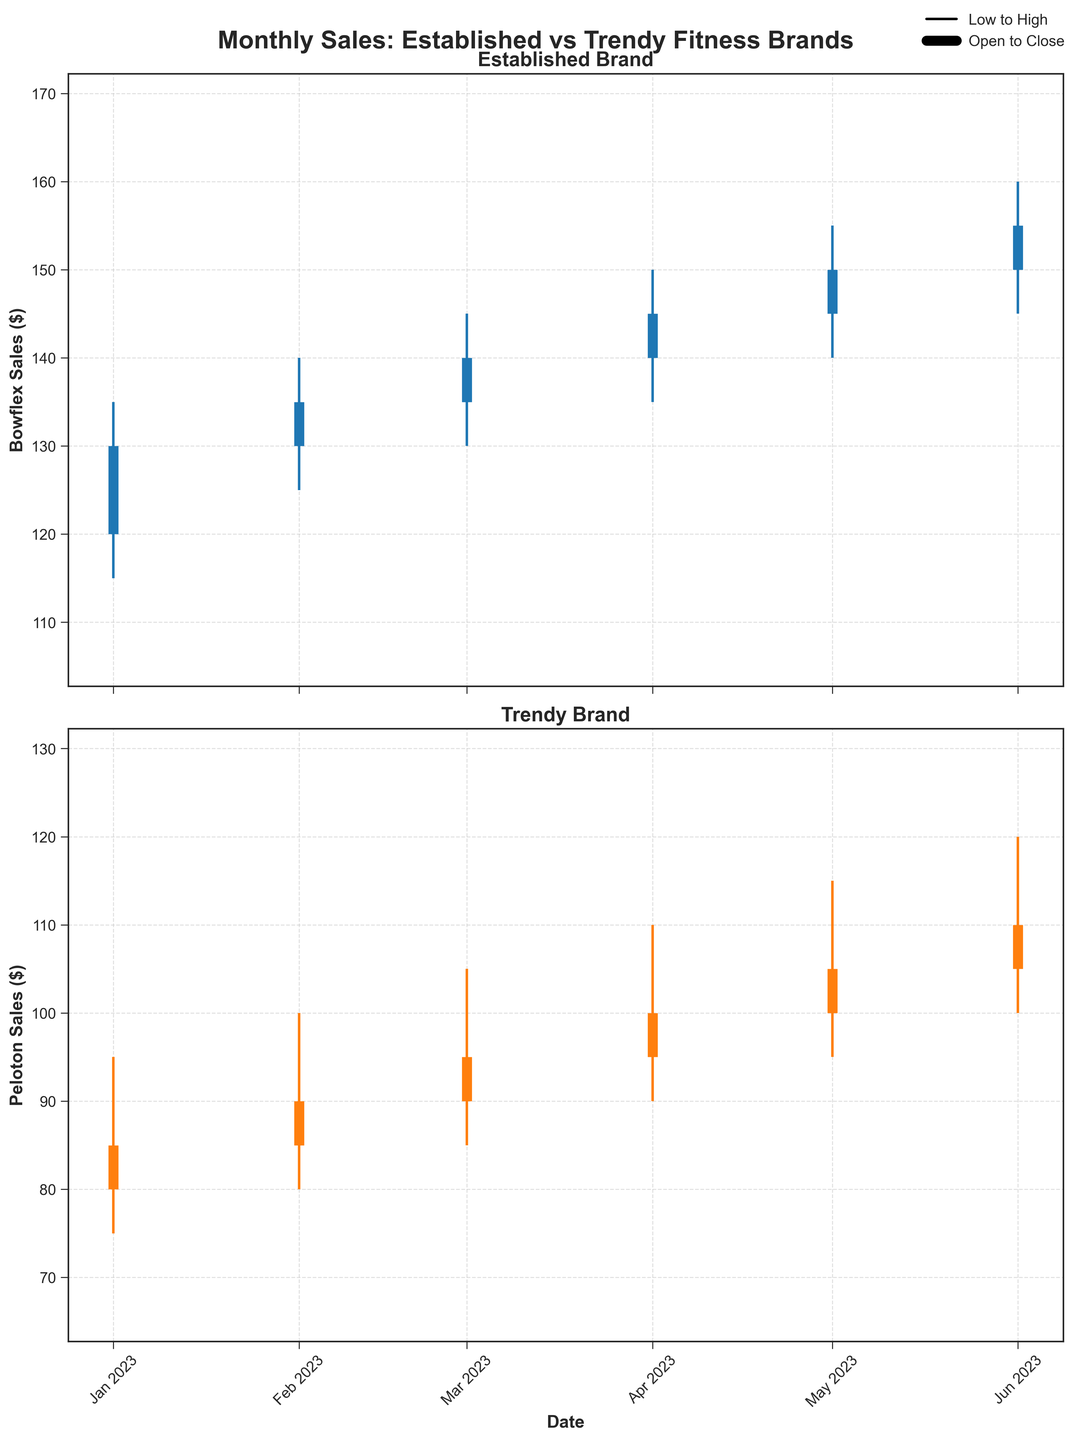What is the title of the overall figure? The title appears at the top of the figure in bold and reads "Monthly Sales: Established vs Trendy Fitness Brands"
Answer: Monthly Sales: Established vs Trendy Fitness Brands What do the vertical lines represent in the figure? The vertical lines on the chart represent the range between the low and high prices for each month.
Answer: Low to High Which brand has a higher closing price in March 2023? Look at the closing prices for both brands in March 2023 and compare them. For Bowflex, it is $140, and for Peloton, it is $95.
Answer: Bowflex How much did Bowflex's closing price increase from January to June 2023? Subtract Bowflex's closing price in January from its closing price in June. In January, the closing price was $130, and in June, it was $155. So, the increase is $155 - $130 = $25.
Answer: $25 What does the thicker part of the vertical lines depict? The thicker part of the lines represents the range between the open and close prices for each month. It is clearly indicated in the legend of the figure.
Answer: Open to Close Is there any month where Peloton sold at a higher price than Bowflex at closing? Checking the data for closing prices from January to June for both brands, no month shows Peloton closing at a higher price than Bowflex.
Answer: No Which brand shows a more significant high-to-low range variation in April 2023? Check the high and low values for both brands in April. Bowflex's range is $150 - $135 = $15, while Peloton's range is $110 - $90 = $20. Peloton has a larger variation.
Answer: Peloton By how much did Peloton's closing price increase from February to May 2023? Subtract Peloton's closing price in February from its closing price in May. In February, it was $90; in May, it was $105. Therefore, the increase is $105 - $90 = $15.
Answer: $15 Which month had the highest closing price for Bowflex? Look at Bowflex’s closing prices from January to June and find the highest value. The highest closing price is $155 in June 2023.
Answer: June 2023 Do both brands show a general upward trend in closing prices from January to June 2023? Check if the closing prices for both brands increase from January to June. Bowflex goes from $130 to $155, while Peloton goes from $85 to $110, indicating an upward trend for both.
Answer: Yes 